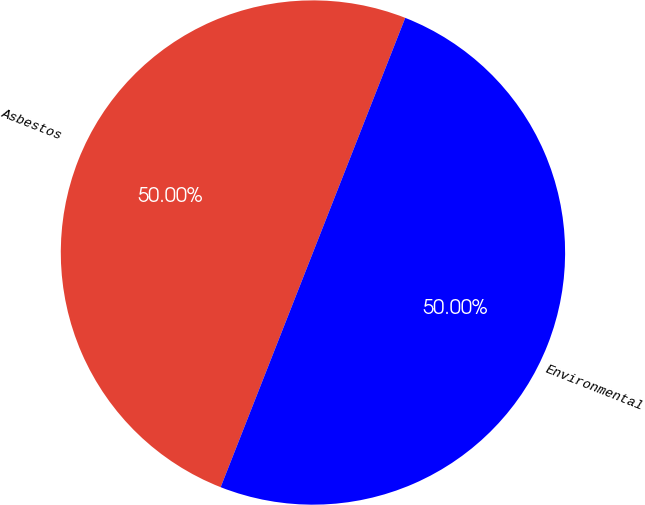<chart> <loc_0><loc_0><loc_500><loc_500><pie_chart><fcel>Asbestos<fcel>Environmental<nl><fcel>50.0%<fcel>50.0%<nl></chart> 